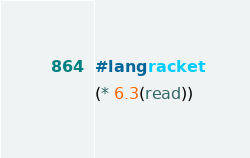Convert code to text. <code><loc_0><loc_0><loc_500><loc_500><_Racket_>#lang racket
(* 6.3(read))</code> 